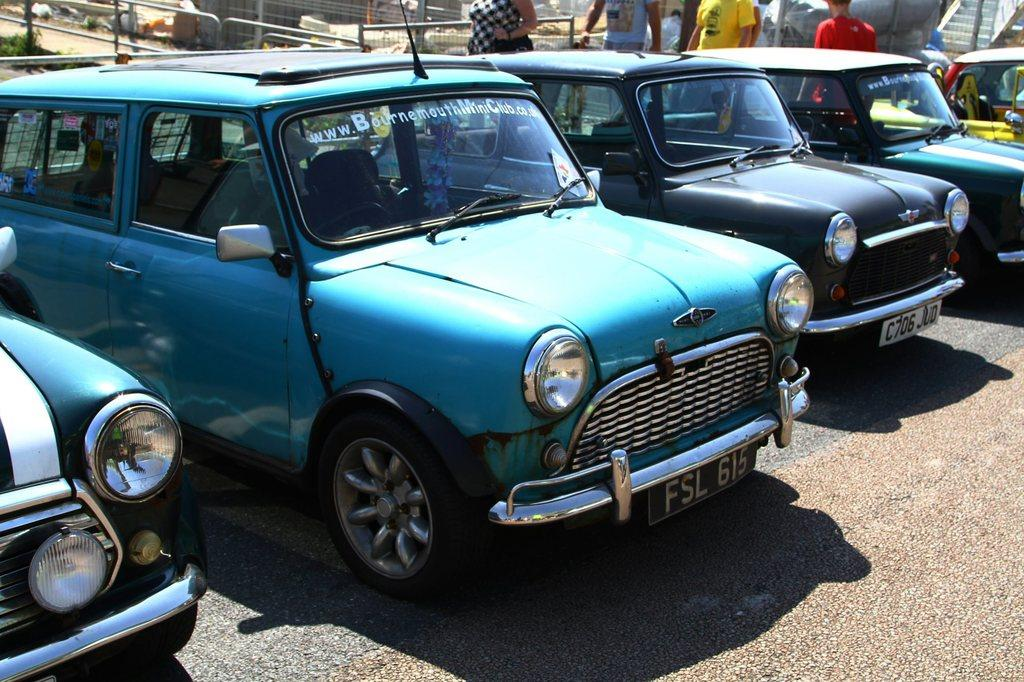What type of objects can be seen on the road in the image? There are motor vehicles on the road in the image. What else can be seen on the road besides motor vehicles? There are people standing on the road in the image. What type of vegetation is present in the image? Shrubs are present in the image. What type of barriers can be seen in the image? There are fences in the image. What type of hat is the person wearing on their birthday in the image? There is no person wearing a hat or celebrating a birthday in the image. What type of play is being performed on the road in the image? There is no play being performed on the road in the image. 